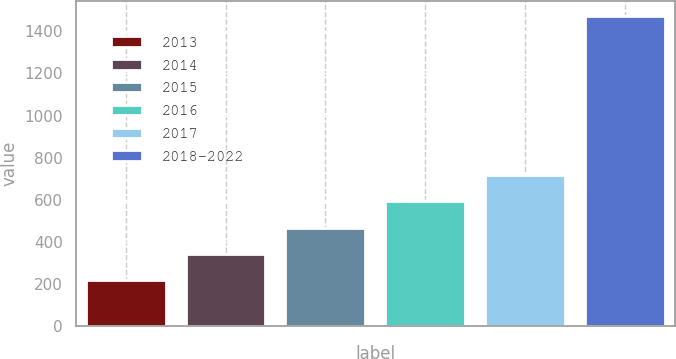Convert chart to OTSL. <chart><loc_0><loc_0><loc_500><loc_500><bar_chart><fcel>2013<fcel>2014<fcel>2015<fcel>2016<fcel>2017<fcel>2018-2022<nl><fcel>217.5<fcel>342.79<fcel>468.08<fcel>593.37<fcel>718.66<fcel>1470.4<nl></chart> 